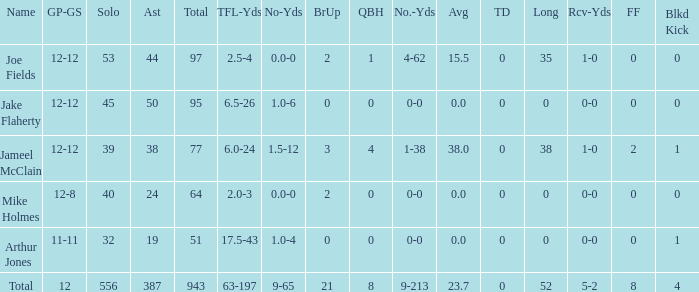How many athletes called jake flaherty? 1.0. 